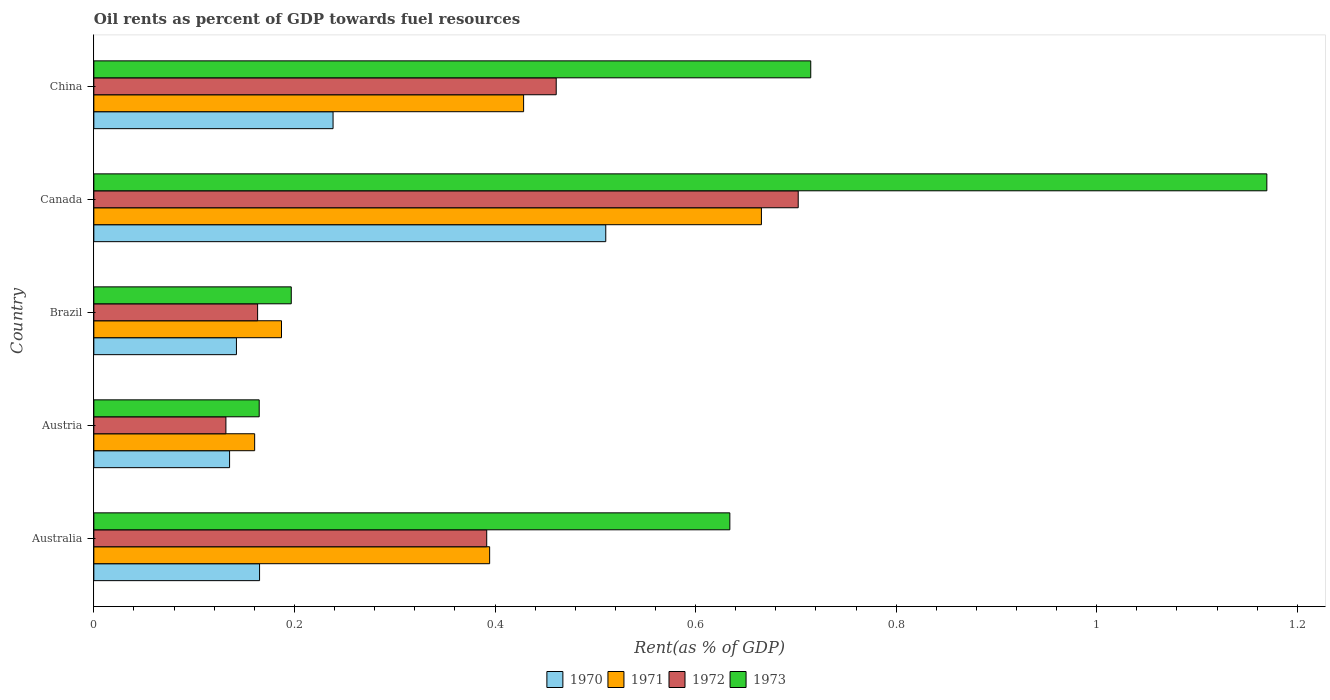How many groups of bars are there?
Provide a succinct answer. 5. Are the number of bars on each tick of the Y-axis equal?
Make the answer very short. Yes. How many bars are there on the 3rd tick from the bottom?
Offer a terse response. 4. What is the oil rent in 1972 in Austria?
Provide a short and direct response. 0.13. Across all countries, what is the maximum oil rent in 1973?
Ensure brevity in your answer.  1.17. Across all countries, what is the minimum oil rent in 1971?
Your answer should be compact. 0.16. In which country was the oil rent in 1970 minimum?
Offer a terse response. Austria. What is the total oil rent in 1971 in the graph?
Give a very brief answer. 1.84. What is the difference between the oil rent in 1973 in Australia and that in Austria?
Make the answer very short. 0.47. What is the difference between the oil rent in 1973 in Australia and the oil rent in 1971 in Austria?
Your response must be concise. 0.47. What is the average oil rent in 1970 per country?
Offer a terse response. 0.24. What is the difference between the oil rent in 1972 and oil rent in 1970 in Australia?
Offer a terse response. 0.23. In how many countries, is the oil rent in 1970 greater than 0.7200000000000001 %?
Provide a succinct answer. 0. What is the ratio of the oil rent in 1973 in Canada to that in China?
Provide a short and direct response. 1.64. Is the oil rent in 1973 in Australia less than that in Canada?
Provide a succinct answer. Yes. Is the difference between the oil rent in 1972 in Canada and China greater than the difference between the oil rent in 1970 in Canada and China?
Offer a terse response. No. What is the difference between the highest and the second highest oil rent in 1972?
Provide a succinct answer. 0.24. What is the difference between the highest and the lowest oil rent in 1973?
Your answer should be compact. 1. In how many countries, is the oil rent in 1973 greater than the average oil rent in 1973 taken over all countries?
Make the answer very short. 3. Is it the case that in every country, the sum of the oil rent in 1973 and oil rent in 1972 is greater than the sum of oil rent in 1971 and oil rent in 1970?
Provide a short and direct response. No. What does the 1st bar from the top in China represents?
Give a very brief answer. 1973. Is it the case that in every country, the sum of the oil rent in 1971 and oil rent in 1972 is greater than the oil rent in 1970?
Provide a short and direct response. Yes. How many bars are there?
Provide a succinct answer. 20. What is the title of the graph?
Provide a succinct answer. Oil rents as percent of GDP towards fuel resources. Does "2013" appear as one of the legend labels in the graph?
Provide a succinct answer. No. What is the label or title of the X-axis?
Provide a succinct answer. Rent(as % of GDP). What is the Rent(as % of GDP) of 1970 in Australia?
Give a very brief answer. 0.17. What is the Rent(as % of GDP) of 1971 in Australia?
Offer a terse response. 0.39. What is the Rent(as % of GDP) in 1972 in Australia?
Make the answer very short. 0.39. What is the Rent(as % of GDP) of 1973 in Australia?
Your answer should be compact. 0.63. What is the Rent(as % of GDP) in 1970 in Austria?
Offer a very short reply. 0.14. What is the Rent(as % of GDP) in 1971 in Austria?
Keep it short and to the point. 0.16. What is the Rent(as % of GDP) in 1972 in Austria?
Offer a very short reply. 0.13. What is the Rent(as % of GDP) of 1973 in Austria?
Ensure brevity in your answer.  0.16. What is the Rent(as % of GDP) in 1970 in Brazil?
Provide a short and direct response. 0.14. What is the Rent(as % of GDP) of 1971 in Brazil?
Your response must be concise. 0.19. What is the Rent(as % of GDP) of 1972 in Brazil?
Provide a succinct answer. 0.16. What is the Rent(as % of GDP) in 1973 in Brazil?
Keep it short and to the point. 0.2. What is the Rent(as % of GDP) in 1970 in Canada?
Offer a terse response. 0.51. What is the Rent(as % of GDP) of 1971 in Canada?
Your answer should be very brief. 0.67. What is the Rent(as % of GDP) in 1972 in Canada?
Offer a terse response. 0.7. What is the Rent(as % of GDP) in 1973 in Canada?
Keep it short and to the point. 1.17. What is the Rent(as % of GDP) in 1970 in China?
Your response must be concise. 0.24. What is the Rent(as % of GDP) in 1971 in China?
Offer a terse response. 0.43. What is the Rent(as % of GDP) in 1972 in China?
Keep it short and to the point. 0.46. What is the Rent(as % of GDP) in 1973 in China?
Your answer should be very brief. 0.71. Across all countries, what is the maximum Rent(as % of GDP) in 1970?
Keep it short and to the point. 0.51. Across all countries, what is the maximum Rent(as % of GDP) in 1971?
Make the answer very short. 0.67. Across all countries, what is the maximum Rent(as % of GDP) in 1972?
Provide a short and direct response. 0.7. Across all countries, what is the maximum Rent(as % of GDP) of 1973?
Give a very brief answer. 1.17. Across all countries, what is the minimum Rent(as % of GDP) of 1970?
Offer a terse response. 0.14. Across all countries, what is the minimum Rent(as % of GDP) in 1971?
Give a very brief answer. 0.16. Across all countries, what is the minimum Rent(as % of GDP) in 1972?
Your answer should be compact. 0.13. Across all countries, what is the minimum Rent(as % of GDP) in 1973?
Provide a short and direct response. 0.16. What is the total Rent(as % of GDP) in 1970 in the graph?
Your answer should be very brief. 1.19. What is the total Rent(as % of GDP) in 1971 in the graph?
Provide a short and direct response. 1.84. What is the total Rent(as % of GDP) of 1972 in the graph?
Offer a terse response. 1.85. What is the total Rent(as % of GDP) of 1973 in the graph?
Ensure brevity in your answer.  2.88. What is the difference between the Rent(as % of GDP) in 1970 in Australia and that in Austria?
Give a very brief answer. 0.03. What is the difference between the Rent(as % of GDP) of 1971 in Australia and that in Austria?
Make the answer very short. 0.23. What is the difference between the Rent(as % of GDP) of 1972 in Australia and that in Austria?
Give a very brief answer. 0.26. What is the difference between the Rent(as % of GDP) in 1973 in Australia and that in Austria?
Keep it short and to the point. 0.47. What is the difference between the Rent(as % of GDP) of 1970 in Australia and that in Brazil?
Keep it short and to the point. 0.02. What is the difference between the Rent(as % of GDP) of 1971 in Australia and that in Brazil?
Your answer should be compact. 0.21. What is the difference between the Rent(as % of GDP) in 1972 in Australia and that in Brazil?
Keep it short and to the point. 0.23. What is the difference between the Rent(as % of GDP) in 1973 in Australia and that in Brazil?
Provide a short and direct response. 0.44. What is the difference between the Rent(as % of GDP) in 1970 in Australia and that in Canada?
Your answer should be compact. -0.35. What is the difference between the Rent(as % of GDP) of 1971 in Australia and that in Canada?
Your response must be concise. -0.27. What is the difference between the Rent(as % of GDP) in 1972 in Australia and that in Canada?
Ensure brevity in your answer.  -0.31. What is the difference between the Rent(as % of GDP) of 1973 in Australia and that in Canada?
Your answer should be very brief. -0.54. What is the difference between the Rent(as % of GDP) in 1970 in Australia and that in China?
Your answer should be very brief. -0.07. What is the difference between the Rent(as % of GDP) of 1971 in Australia and that in China?
Ensure brevity in your answer.  -0.03. What is the difference between the Rent(as % of GDP) of 1972 in Australia and that in China?
Offer a terse response. -0.07. What is the difference between the Rent(as % of GDP) of 1973 in Australia and that in China?
Ensure brevity in your answer.  -0.08. What is the difference between the Rent(as % of GDP) of 1970 in Austria and that in Brazil?
Offer a terse response. -0.01. What is the difference between the Rent(as % of GDP) of 1971 in Austria and that in Brazil?
Your response must be concise. -0.03. What is the difference between the Rent(as % of GDP) in 1972 in Austria and that in Brazil?
Offer a very short reply. -0.03. What is the difference between the Rent(as % of GDP) in 1973 in Austria and that in Brazil?
Make the answer very short. -0.03. What is the difference between the Rent(as % of GDP) of 1970 in Austria and that in Canada?
Your response must be concise. -0.38. What is the difference between the Rent(as % of GDP) in 1971 in Austria and that in Canada?
Offer a terse response. -0.51. What is the difference between the Rent(as % of GDP) in 1972 in Austria and that in Canada?
Offer a very short reply. -0.57. What is the difference between the Rent(as % of GDP) in 1973 in Austria and that in Canada?
Ensure brevity in your answer.  -1. What is the difference between the Rent(as % of GDP) in 1970 in Austria and that in China?
Your response must be concise. -0.1. What is the difference between the Rent(as % of GDP) of 1971 in Austria and that in China?
Provide a succinct answer. -0.27. What is the difference between the Rent(as % of GDP) in 1972 in Austria and that in China?
Make the answer very short. -0.33. What is the difference between the Rent(as % of GDP) of 1973 in Austria and that in China?
Provide a succinct answer. -0.55. What is the difference between the Rent(as % of GDP) in 1970 in Brazil and that in Canada?
Offer a very short reply. -0.37. What is the difference between the Rent(as % of GDP) of 1971 in Brazil and that in Canada?
Your response must be concise. -0.48. What is the difference between the Rent(as % of GDP) of 1972 in Brazil and that in Canada?
Provide a succinct answer. -0.54. What is the difference between the Rent(as % of GDP) in 1973 in Brazil and that in Canada?
Make the answer very short. -0.97. What is the difference between the Rent(as % of GDP) in 1970 in Brazil and that in China?
Give a very brief answer. -0.1. What is the difference between the Rent(as % of GDP) of 1971 in Brazil and that in China?
Keep it short and to the point. -0.24. What is the difference between the Rent(as % of GDP) in 1972 in Brazil and that in China?
Your answer should be very brief. -0.3. What is the difference between the Rent(as % of GDP) in 1973 in Brazil and that in China?
Offer a terse response. -0.52. What is the difference between the Rent(as % of GDP) in 1970 in Canada and that in China?
Your answer should be very brief. 0.27. What is the difference between the Rent(as % of GDP) of 1971 in Canada and that in China?
Keep it short and to the point. 0.24. What is the difference between the Rent(as % of GDP) in 1972 in Canada and that in China?
Provide a short and direct response. 0.24. What is the difference between the Rent(as % of GDP) of 1973 in Canada and that in China?
Make the answer very short. 0.45. What is the difference between the Rent(as % of GDP) of 1970 in Australia and the Rent(as % of GDP) of 1971 in Austria?
Your answer should be compact. 0. What is the difference between the Rent(as % of GDP) in 1970 in Australia and the Rent(as % of GDP) in 1972 in Austria?
Make the answer very short. 0.03. What is the difference between the Rent(as % of GDP) of 1970 in Australia and the Rent(as % of GDP) of 1973 in Austria?
Offer a terse response. 0. What is the difference between the Rent(as % of GDP) in 1971 in Australia and the Rent(as % of GDP) in 1972 in Austria?
Your response must be concise. 0.26. What is the difference between the Rent(as % of GDP) in 1971 in Australia and the Rent(as % of GDP) in 1973 in Austria?
Keep it short and to the point. 0.23. What is the difference between the Rent(as % of GDP) of 1972 in Australia and the Rent(as % of GDP) of 1973 in Austria?
Your answer should be compact. 0.23. What is the difference between the Rent(as % of GDP) of 1970 in Australia and the Rent(as % of GDP) of 1971 in Brazil?
Keep it short and to the point. -0.02. What is the difference between the Rent(as % of GDP) of 1970 in Australia and the Rent(as % of GDP) of 1972 in Brazil?
Ensure brevity in your answer.  0. What is the difference between the Rent(as % of GDP) in 1970 in Australia and the Rent(as % of GDP) in 1973 in Brazil?
Provide a succinct answer. -0.03. What is the difference between the Rent(as % of GDP) in 1971 in Australia and the Rent(as % of GDP) in 1972 in Brazil?
Make the answer very short. 0.23. What is the difference between the Rent(as % of GDP) in 1971 in Australia and the Rent(as % of GDP) in 1973 in Brazil?
Give a very brief answer. 0.2. What is the difference between the Rent(as % of GDP) of 1972 in Australia and the Rent(as % of GDP) of 1973 in Brazil?
Keep it short and to the point. 0.19. What is the difference between the Rent(as % of GDP) in 1970 in Australia and the Rent(as % of GDP) in 1971 in Canada?
Keep it short and to the point. -0.5. What is the difference between the Rent(as % of GDP) of 1970 in Australia and the Rent(as % of GDP) of 1972 in Canada?
Provide a succinct answer. -0.54. What is the difference between the Rent(as % of GDP) in 1970 in Australia and the Rent(as % of GDP) in 1973 in Canada?
Provide a short and direct response. -1. What is the difference between the Rent(as % of GDP) in 1971 in Australia and the Rent(as % of GDP) in 1972 in Canada?
Give a very brief answer. -0.31. What is the difference between the Rent(as % of GDP) in 1971 in Australia and the Rent(as % of GDP) in 1973 in Canada?
Keep it short and to the point. -0.77. What is the difference between the Rent(as % of GDP) of 1972 in Australia and the Rent(as % of GDP) of 1973 in Canada?
Provide a succinct answer. -0.78. What is the difference between the Rent(as % of GDP) of 1970 in Australia and the Rent(as % of GDP) of 1971 in China?
Provide a short and direct response. -0.26. What is the difference between the Rent(as % of GDP) in 1970 in Australia and the Rent(as % of GDP) in 1972 in China?
Your answer should be compact. -0.3. What is the difference between the Rent(as % of GDP) of 1970 in Australia and the Rent(as % of GDP) of 1973 in China?
Ensure brevity in your answer.  -0.55. What is the difference between the Rent(as % of GDP) in 1971 in Australia and the Rent(as % of GDP) in 1972 in China?
Offer a terse response. -0.07. What is the difference between the Rent(as % of GDP) of 1971 in Australia and the Rent(as % of GDP) of 1973 in China?
Your answer should be compact. -0.32. What is the difference between the Rent(as % of GDP) in 1972 in Australia and the Rent(as % of GDP) in 1973 in China?
Keep it short and to the point. -0.32. What is the difference between the Rent(as % of GDP) in 1970 in Austria and the Rent(as % of GDP) in 1971 in Brazil?
Provide a short and direct response. -0.05. What is the difference between the Rent(as % of GDP) in 1970 in Austria and the Rent(as % of GDP) in 1972 in Brazil?
Offer a terse response. -0.03. What is the difference between the Rent(as % of GDP) in 1970 in Austria and the Rent(as % of GDP) in 1973 in Brazil?
Make the answer very short. -0.06. What is the difference between the Rent(as % of GDP) in 1971 in Austria and the Rent(as % of GDP) in 1972 in Brazil?
Your answer should be very brief. -0. What is the difference between the Rent(as % of GDP) in 1971 in Austria and the Rent(as % of GDP) in 1973 in Brazil?
Give a very brief answer. -0.04. What is the difference between the Rent(as % of GDP) in 1972 in Austria and the Rent(as % of GDP) in 1973 in Brazil?
Make the answer very short. -0.07. What is the difference between the Rent(as % of GDP) of 1970 in Austria and the Rent(as % of GDP) of 1971 in Canada?
Your answer should be compact. -0.53. What is the difference between the Rent(as % of GDP) in 1970 in Austria and the Rent(as % of GDP) in 1972 in Canada?
Provide a short and direct response. -0.57. What is the difference between the Rent(as % of GDP) of 1970 in Austria and the Rent(as % of GDP) of 1973 in Canada?
Your response must be concise. -1.03. What is the difference between the Rent(as % of GDP) in 1971 in Austria and the Rent(as % of GDP) in 1972 in Canada?
Ensure brevity in your answer.  -0.54. What is the difference between the Rent(as % of GDP) of 1971 in Austria and the Rent(as % of GDP) of 1973 in Canada?
Make the answer very short. -1.01. What is the difference between the Rent(as % of GDP) of 1972 in Austria and the Rent(as % of GDP) of 1973 in Canada?
Your answer should be compact. -1.04. What is the difference between the Rent(as % of GDP) in 1970 in Austria and the Rent(as % of GDP) in 1971 in China?
Your answer should be very brief. -0.29. What is the difference between the Rent(as % of GDP) in 1970 in Austria and the Rent(as % of GDP) in 1972 in China?
Your response must be concise. -0.33. What is the difference between the Rent(as % of GDP) in 1970 in Austria and the Rent(as % of GDP) in 1973 in China?
Offer a terse response. -0.58. What is the difference between the Rent(as % of GDP) in 1971 in Austria and the Rent(as % of GDP) in 1972 in China?
Your response must be concise. -0.3. What is the difference between the Rent(as % of GDP) of 1971 in Austria and the Rent(as % of GDP) of 1973 in China?
Offer a very short reply. -0.55. What is the difference between the Rent(as % of GDP) in 1972 in Austria and the Rent(as % of GDP) in 1973 in China?
Your response must be concise. -0.58. What is the difference between the Rent(as % of GDP) in 1970 in Brazil and the Rent(as % of GDP) in 1971 in Canada?
Offer a very short reply. -0.52. What is the difference between the Rent(as % of GDP) of 1970 in Brazil and the Rent(as % of GDP) of 1972 in Canada?
Your answer should be very brief. -0.56. What is the difference between the Rent(as % of GDP) of 1970 in Brazil and the Rent(as % of GDP) of 1973 in Canada?
Offer a terse response. -1.03. What is the difference between the Rent(as % of GDP) of 1971 in Brazil and the Rent(as % of GDP) of 1972 in Canada?
Make the answer very short. -0.52. What is the difference between the Rent(as % of GDP) of 1971 in Brazil and the Rent(as % of GDP) of 1973 in Canada?
Offer a very short reply. -0.98. What is the difference between the Rent(as % of GDP) of 1972 in Brazil and the Rent(as % of GDP) of 1973 in Canada?
Provide a short and direct response. -1.01. What is the difference between the Rent(as % of GDP) of 1970 in Brazil and the Rent(as % of GDP) of 1971 in China?
Make the answer very short. -0.29. What is the difference between the Rent(as % of GDP) in 1970 in Brazil and the Rent(as % of GDP) in 1972 in China?
Ensure brevity in your answer.  -0.32. What is the difference between the Rent(as % of GDP) of 1970 in Brazil and the Rent(as % of GDP) of 1973 in China?
Make the answer very short. -0.57. What is the difference between the Rent(as % of GDP) in 1971 in Brazil and the Rent(as % of GDP) in 1972 in China?
Provide a succinct answer. -0.27. What is the difference between the Rent(as % of GDP) of 1971 in Brazil and the Rent(as % of GDP) of 1973 in China?
Provide a succinct answer. -0.53. What is the difference between the Rent(as % of GDP) of 1972 in Brazil and the Rent(as % of GDP) of 1973 in China?
Your response must be concise. -0.55. What is the difference between the Rent(as % of GDP) in 1970 in Canada and the Rent(as % of GDP) in 1971 in China?
Provide a short and direct response. 0.08. What is the difference between the Rent(as % of GDP) in 1970 in Canada and the Rent(as % of GDP) in 1972 in China?
Ensure brevity in your answer.  0.05. What is the difference between the Rent(as % of GDP) in 1970 in Canada and the Rent(as % of GDP) in 1973 in China?
Give a very brief answer. -0.2. What is the difference between the Rent(as % of GDP) in 1971 in Canada and the Rent(as % of GDP) in 1972 in China?
Provide a succinct answer. 0.2. What is the difference between the Rent(as % of GDP) of 1971 in Canada and the Rent(as % of GDP) of 1973 in China?
Give a very brief answer. -0.05. What is the difference between the Rent(as % of GDP) in 1972 in Canada and the Rent(as % of GDP) in 1973 in China?
Your answer should be compact. -0.01. What is the average Rent(as % of GDP) of 1970 per country?
Your response must be concise. 0.24. What is the average Rent(as % of GDP) in 1971 per country?
Give a very brief answer. 0.37. What is the average Rent(as % of GDP) in 1972 per country?
Offer a terse response. 0.37. What is the average Rent(as % of GDP) in 1973 per country?
Offer a very short reply. 0.58. What is the difference between the Rent(as % of GDP) in 1970 and Rent(as % of GDP) in 1971 in Australia?
Offer a very short reply. -0.23. What is the difference between the Rent(as % of GDP) of 1970 and Rent(as % of GDP) of 1972 in Australia?
Your answer should be very brief. -0.23. What is the difference between the Rent(as % of GDP) of 1970 and Rent(as % of GDP) of 1973 in Australia?
Offer a terse response. -0.47. What is the difference between the Rent(as % of GDP) in 1971 and Rent(as % of GDP) in 1972 in Australia?
Offer a very short reply. 0. What is the difference between the Rent(as % of GDP) of 1971 and Rent(as % of GDP) of 1973 in Australia?
Your response must be concise. -0.24. What is the difference between the Rent(as % of GDP) of 1972 and Rent(as % of GDP) of 1973 in Australia?
Make the answer very short. -0.24. What is the difference between the Rent(as % of GDP) of 1970 and Rent(as % of GDP) of 1971 in Austria?
Your answer should be compact. -0.03. What is the difference between the Rent(as % of GDP) of 1970 and Rent(as % of GDP) of 1972 in Austria?
Keep it short and to the point. 0. What is the difference between the Rent(as % of GDP) in 1970 and Rent(as % of GDP) in 1973 in Austria?
Your answer should be compact. -0.03. What is the difference between the Rent(as % of GDP) in 1971 and Rent(as % of GDP) in 1972 in Austria?
Provide a short and direct response. 0.03. What is the difference between the Rent(as % of GDP) in 1971 and Rent(as % of GDP) in 1973 in Austria?
Make the answer very short. -0. What is the difference between the Rent(as % of GDP) in 1972 and Rent(as % of GDP) in 1973 in Austria?
Ensure brevity in your answer.  -0.03. What is the difference between the Rent(as % of GDP) of 1970 and Rent(as % of GDP) of 1971 in Brazil?
Your answer should be very brief. -0.04. What is the difference between the Rent(as % of GDP) in 1970 and Rent(as % of GDP) in 1972 in Brazil?
Provide a short and direct response. -0.02. What is the difference between the Rent(as % of GDP) in 1970 and Rent(as % of GDP) in 1973 in Brazil?
Keep it short and to the point. -0.05. What is the difference between the Rent(as % of GDP) of 1971 and Rent(as % of GDP) of 1972 in Brazil?
Your answer should be very brief. 0.02. What is the difference between the Rent(as % of GDP) of 1971 and Rent(as % of GDP) of 1973 in Brazil?
Your response must be concise. -0.01. What is the difference between the Rent(as % of GDP) of 1972 and Rent(as % of GDP) of 1973 in Brazil?
Make the answer very short. -0.03. What is the difference between the Rent(as % of GDP) in 1970 and Rent(as % of GDP) in 1971 in Canada?
Offer a terse response. -0.16. What is the difference between the Rent(as % of GDP) in 1970 and Rent(as % of GDP) in 1972 in Canada?
Make the answer very short. -0.19. What is the difference between the Rent(as % of GDP) of 1970 and Rent(as % of GDP) of 1973 in Canada?
Your answer should be very brief. -0.66. What is the difference between the Rent(as % of GDP) of 1971 and Rent(as % of GDP) of 1972 in Canada?
Offer a very short reply. -0.04. What is the difference between the Rent(as % of GDP) of 1971 and Rent(as % of GDP) of 1973 in Canada?
Offer a terse response. -0.5. What is the difference between the Rent(as % of GDP) of 1972 and Rent(as % of GDP) of 1973 in Canada?
Offer a very short reply. -0.47. What is the difference between the Rent(as % of GDP) of 1970 and Rent(as % of GDP) of 1971 in China?
Give a very brief answer. -0.19. What is the difference between the Rent(as % of GDP) of 1970 and Rent(as % of GDP) of 1972 in China?
Offer a very short reply. -0.22. What is the difference between the Rent(as % of GDP) of 1970 and Rent(as % of GDP) of 1973 in China?
Keep it short and to the point. -0.48. What is the difference between the Rent(as % of GDP) in 1971 and Rent(as % of GDP) in 1972 in China?
Offer a terse response. -0.03. What is the difference between the Rent(as % of GDP) of 1971 and Rent(as % of GDP) of 1973 in China?
Make the answer very short. -0.29. What is the difference between the Rent(as % of GDP) in 1972 and Rent(as % of GDP) in 1973 in China?
Your answer should be very brief. -0.25. What is the ratio of the Rent(as % of GDP) in 1970 in Australia to that in Austria?
Offer a terse response. 1.22. What is the ratio of the Rent(as % of GDP) in 1971 in Australia to that in Austria?
Keep it short and to the point. 2.46. What is the ratio of the Rent(as % of GDP) in 1972 in Australia to that in Austria?
Your answer should be compact. 2.97. What is the ratio of the Rent(as % of GDP) of 1973 in Australia to that in Austria?
Make the answer very short. 3.85. What is the ratio of the Rent(as % of GDP) of 1970 in Australia to that in Brazil?
Ensure brevity in your answer.  1.16. What is the ratio of the Rent(as % of GDP) in 1971 in Australia to that in Brazil?
Offer a very short reply. 2.11. What is the ratio of the Rent(as % of GDP) in 1972 in Australia to that in Brazil?
Offer a terse response. 2.4. What is the ratio of the Rent(as % of GDP) in 1973 in Australia to that in Brazil?
Your answer should be very brief. 3.22. What is the ratio of the Rent(as % of GDP) in 1970 in Australia to that in Canada?
Your answer should be very brief. 0.32. What is the ratio of the Rent(as % of GDP) in 1971 in Australia to that in Canada?
Keep it short and to the point. 0.59. What is the ratio of the Rent(as % of GDP) of 1972 in Australia to that in Canada?
Keep it short and to the point. 0.56. What is the ratio of the Rent(as % of GDP) of 1973 in Australia to that in Canada?
Your answer should be compact. 0.54. What is the ratio of the Rent(as % of GDP) in 1970 in Australia to that in China?
Ensure brevity in your answer.  0.69. What is the ratio of the Rent(as % of GDP) in 1971 in Australia to that in China?
Your answer should be very brief. 0.92. What is the ratio of the Rent(as % of GDP) in 1972 in Australia to that in China?
Your response must be concise. 0.85. What is the ratio of the Rent(as % of GDP) of 1973 in Australia to that in China?
Ensure brevity in your answer.  0.89. What is the ratio of the Rent(as % of GDP) in 1970 in Austria to that in Brazil?
Give a very brief answer. 0.95. What is the ratio of the Rent(as % of GDP) of 1971 in Austria to that in Brazil?
Offer a very short reply. 0.86. What is the ratio of the Rent(as % of GDP) in 1972 in Austria to that in Brazil?
Your response must be concise. 0.81. What is the ratio of the Rent(as % of GDP) in 1973 in Austria to that in Brazil?
Make the answer very short. 0.84. What is the ratio of the Rent(as % of GDP) in 1970 in Austria to that in Canada?
Give a very brief answer. 0.27. What is the ratio of the Rent(as % of GDP) of 1971 in Austria to that in Canada?
Your response must be concise. 0.24. What is the ratio of the Rent(as % of GDP) in 1972 in Austria to that in Canada?
Your response must be concise. 0.19. What is the ratio of the Rent(as % of GDP) of 1973 in Austria to that in Canada?
Your answer should be compact. 0.14. What is the ratio of the Rent(as % of GDP) of 1970 in Austria to that in China?
Offer a terse response. 0.57. What is the ratio of the Rent(as % of GDP) of 1971 in Austria to that in China?
Keep it short and to the point. 0.37. What is the ratio of the Rent(as % of GDP) in 1972 in Austria to that in China?
Your answer should be compact. 0.29. What is the ratio of the Rent(as % of GDP) of 1973 in Austria to that in China?
Offer a terse response. 0.23. What is the ratio of the Rent(as % of GDP) in 1970 in Brazil to that in Canada?
Provide a short and direct response. 0.28. What is the ratio of the Rent(as % of GDP) of 1971 in Brazil to that in Canada?
Keep it short and to the point. 0.28. What is the ratio of the Rent(as % of GDP) of 1972 in Brazil to that in Canada?
Make the answer very short. 0.23. What is the ratio of the Rent(as % of GDP) in 1973 in Brazil to that in Canada?
Offer a terse response. 0.17. What is the ratio of the Rent(as % of GDP) in 1970 in Brazil to that in China?
Your response must be concise. 0.6. What is the ratio of the Rent(as % of GDP) in 1971 in Brazil to that in China?
Offer a very short reply. 0.44. What is the ratio of the Rent(as % of GDP) in 1972 in Brazil to that in China?
Offer a terse response. 0.35. What is the ratio of the Rent(as % of GDP) in 1973 in Brazil to that in China?
Keep it short and to the point. 0.28. What is the ratio of the Rent(as % of GDP) in 1970 in Canada to that in China?
Your response must be concise. 2.14. What is the ratio of the Rent(as % of GDP) in 1971 in Canada to that in China?
Make the answer very short. 1.55. What is the ratio of the Rent(as % of GDP) in 1972 in Canada to that in China?
Keep it short and to the point. 1.52. What is the ratio of the Rent(as % of GDP) in 1973 in Canada to that in China?
Provide a succinct answer. 1.64. What is the difference between the highest and the second highest Rent(as % of GDP) of 1970?
Keep it short and to the point. 0.27. What is the difference between the highest and the second highest Rent(as % of GDP) in 1971?
Give a very brief answer. 0.24. What is the difference between the highest and the second highest Rent(as % of GDP) of 1972?
Your response must be concise. 0.24. What is the difference between the highest and the second highest Rent(as % of GDP) in 1973?
Ensure brevity in your answer.  0.45. What is the difference between the highest and the lowest Rent(as % of GDP) in 1970?
Offer a terse response. 0.38. What is the difference between the highest and the lowest Rent(as % of GDP) in 1971?
Ensure brevity in your answer.  0.51. What is the difference between the highest and the lowest Rent(as % of GDP) of 1972?
Your response must be concise. 0.57. What is the difference between the highest and the lowest Rent(as % of GDP) of 1973?
Give a very brief answer. 1. 